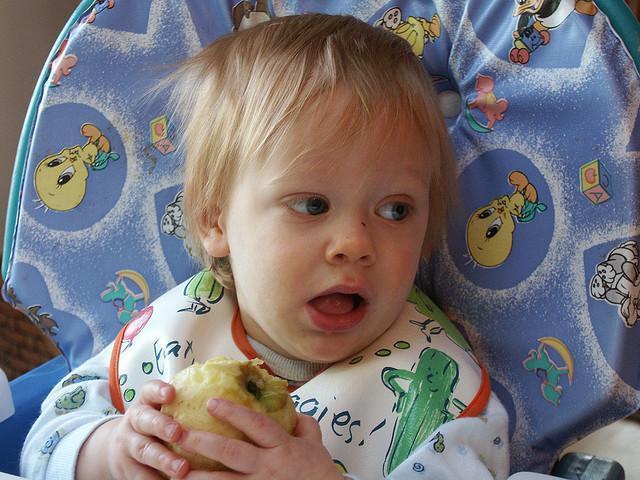How many people are there?
Give a very brief answer. 1. How many zebra near from tree?
Give a very brief answer. 0. 